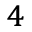Convert formula to latex. <formula><loc_0><loc_0><loc_500><loc_500>^ { 4 }</formula> 